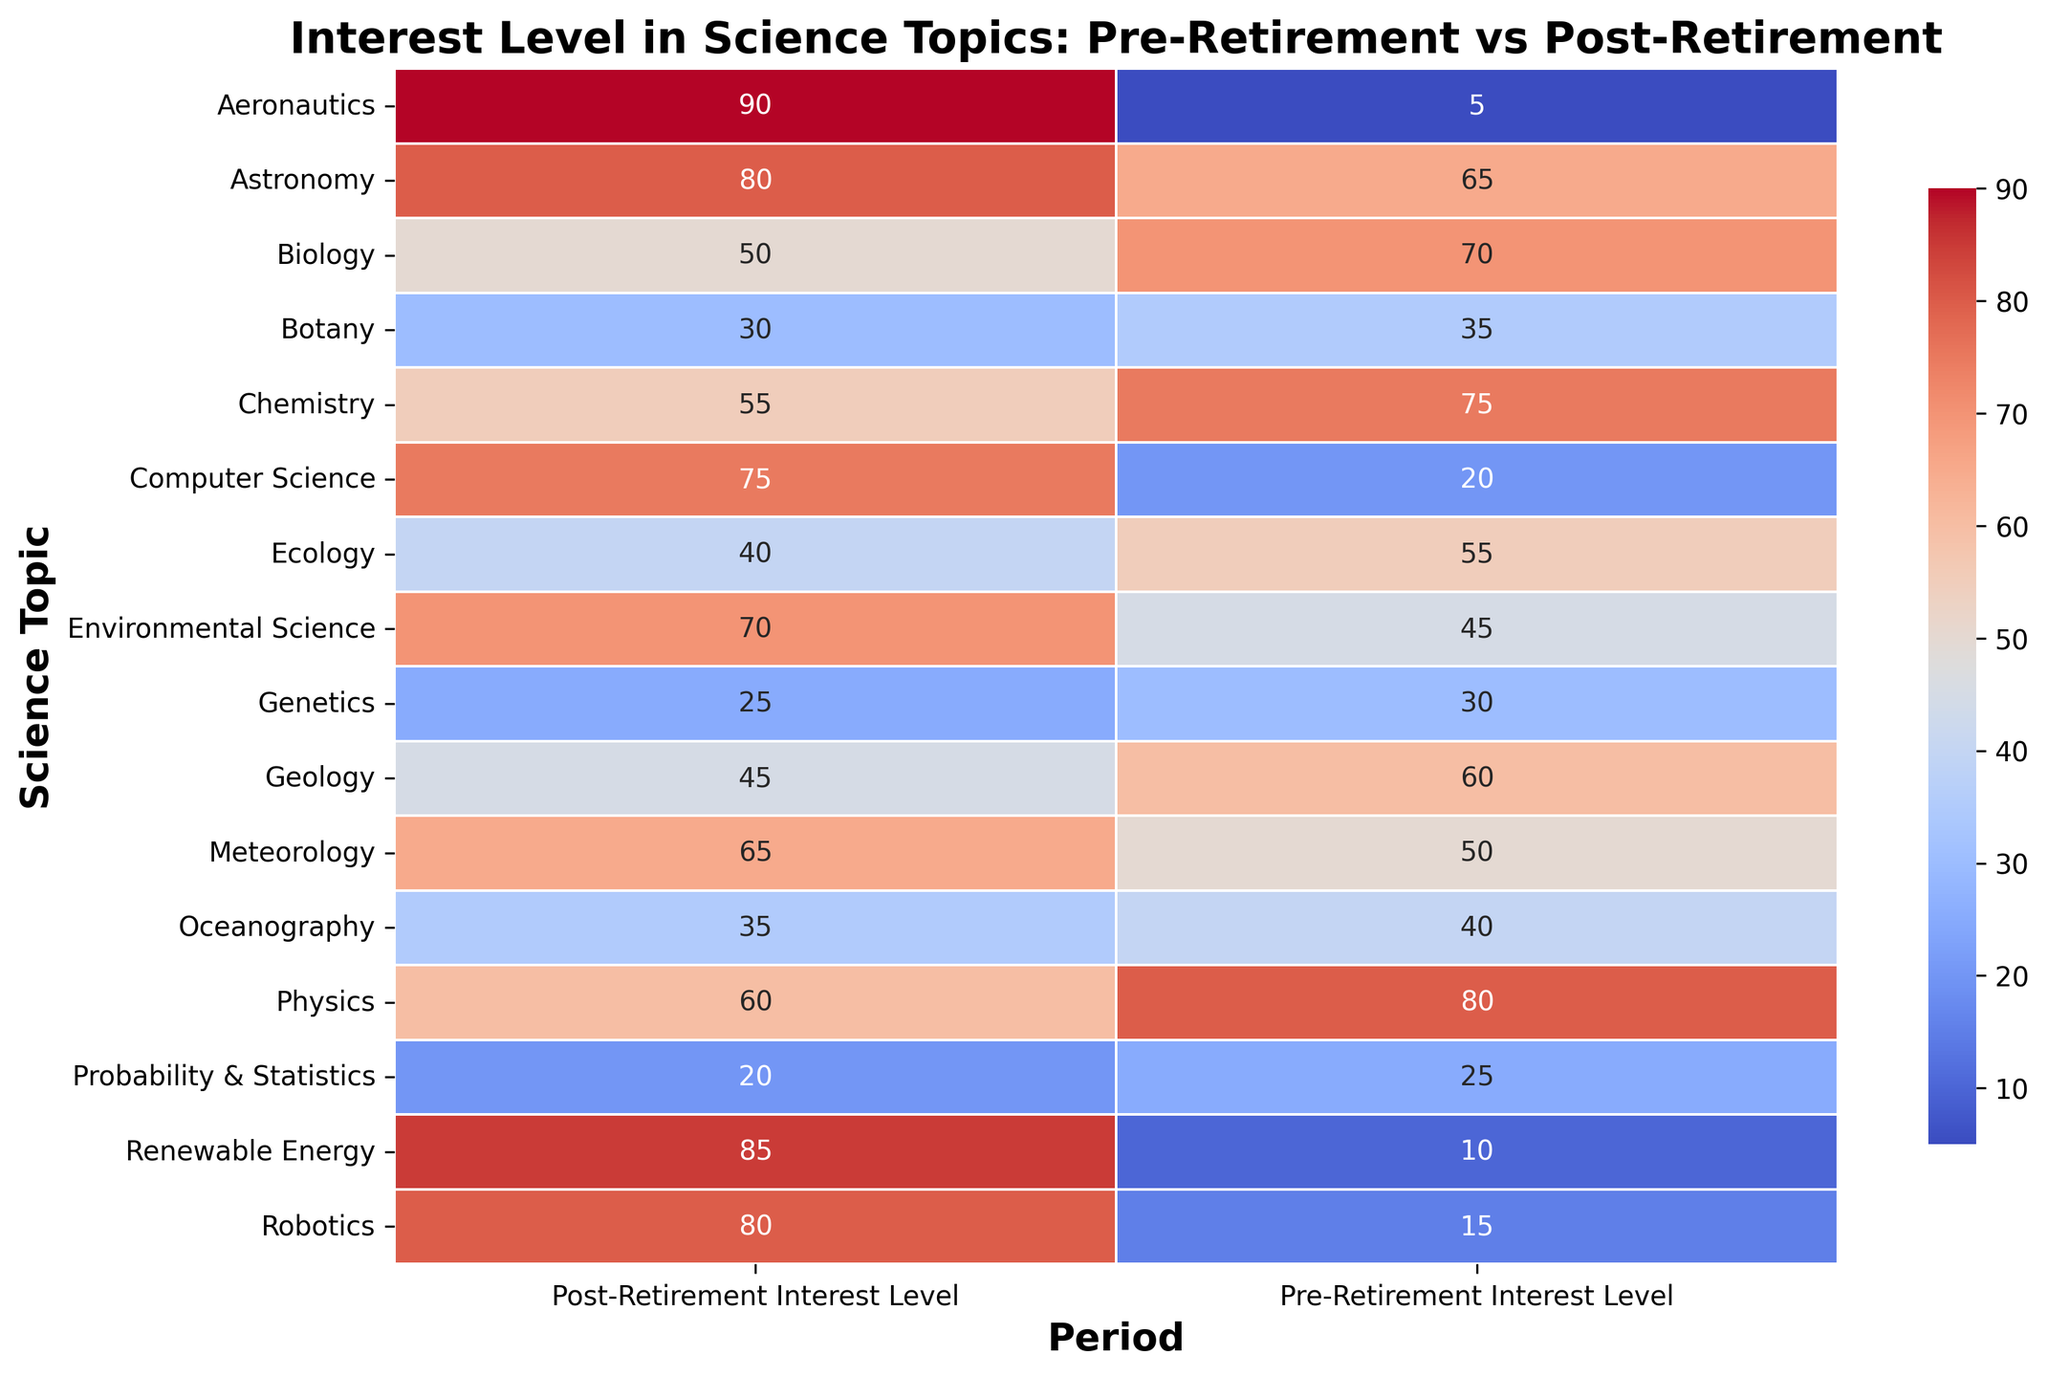Which science topic had the highest increase in interest level post-retirement? Compare the pre-retirement and post-retirement interest levels for each science topic to identify the largest increase. Aeronautics has the largest increase, from 5 to 90.
Answer: Aeronautics Which science topic had the highest decrease in interest level post-retirement? Compare the pre-retirement and post-retirement interest levels for each science topic to identify the largest decrease. Chemistry has the largest decrease, from 75 to 55.
Answer: Chemistry What is the difference in interest level for Astronomy pre-retirement versus post-retirement? Subtract the pre-retirement interest level from the post-retirement interest level for Astronomy: 80 - 65 = 15.
Answer: 15 What is the average pre-retirement interest level across all science topics? Sum the pre-retirement interest levels for all topics and divide by the number of topics: (80 + 75 + 70 + 65 + 60 + 55 + 50 + 45 + 40 + 35 + 30 + 25 + 20 + 15 + 10 + 5) / 16 = 41.875.
Answer: 41.875 Which science topics have a higher interest level post-retirement compared to pre-retirement? Identify science topics where the post-retirement interest level is greater than the pre-retirement interest level. These are Astronomy, Meteorology, Environmental Science, Computer Science, Robotics, Renewable Energy, and Aeronautics.
Answer: Astronomy, Meteorology, Environmental Science, Computer Science, Robotics, Renewable Energy, Aeronautics What is the total interest level for Robotics before and after retirement? Sum the pre-retirement and post-retirement interest levels for Robotics: 15 + 80 = 95.
Answer: 95 Which science topic had an equal interest level both before and after retirement? Check if any science topic has the same pre-retirement and post-retirement interest levels. None have equal levels.
Answer: None By how much did the interest in Computer Science change post-retirement? Subtract the pre-retirement interest level from the post-retirement interest level for Computer Science: 75 - 20 = 55.
Answer: 55 What is the combined interest level for Chemistry and Biology post-retirement? Sum the post-retirement interest levels for Chemistry and Biology: 55 + 50 = 105.
Answer: 105 